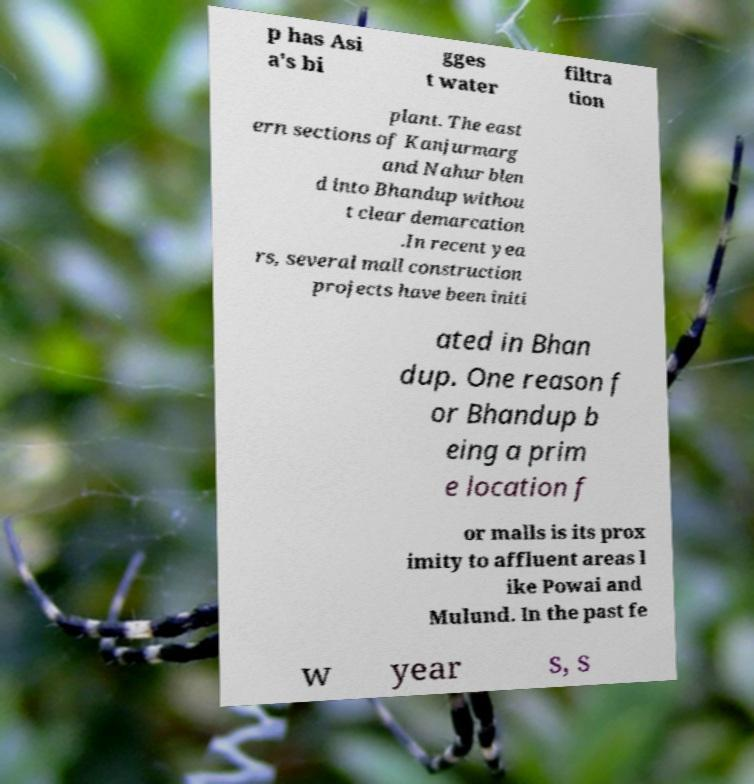Please read and relay the text visible in this image. What does it say? p has Asi a's bi gges t water filtra tion plant. The east ern sections of Kanjurmarg and Nahur blen d into Bhandup withou t clear demarcation .In recent yea rs, several mall construction projects have been initi ated in Bhan dup. One reason f or Bhandup b eing a prim e location f or malls is its prox imity to affluent areas l ike Powai and Mulund. In the past fe w year s, s 